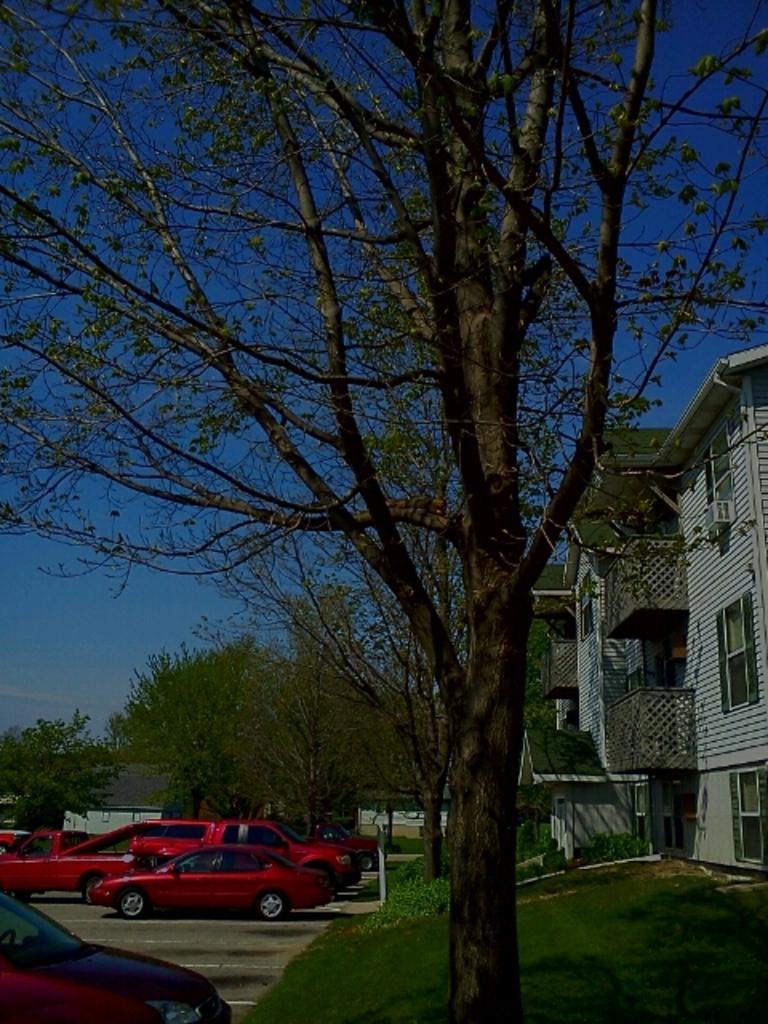Can you describe this image briefly? In this image I can see a tree , in front of the tree I can see a road, on the road I can see red color vehicles ,at the top I can see the sky and on the right side I can see the building 